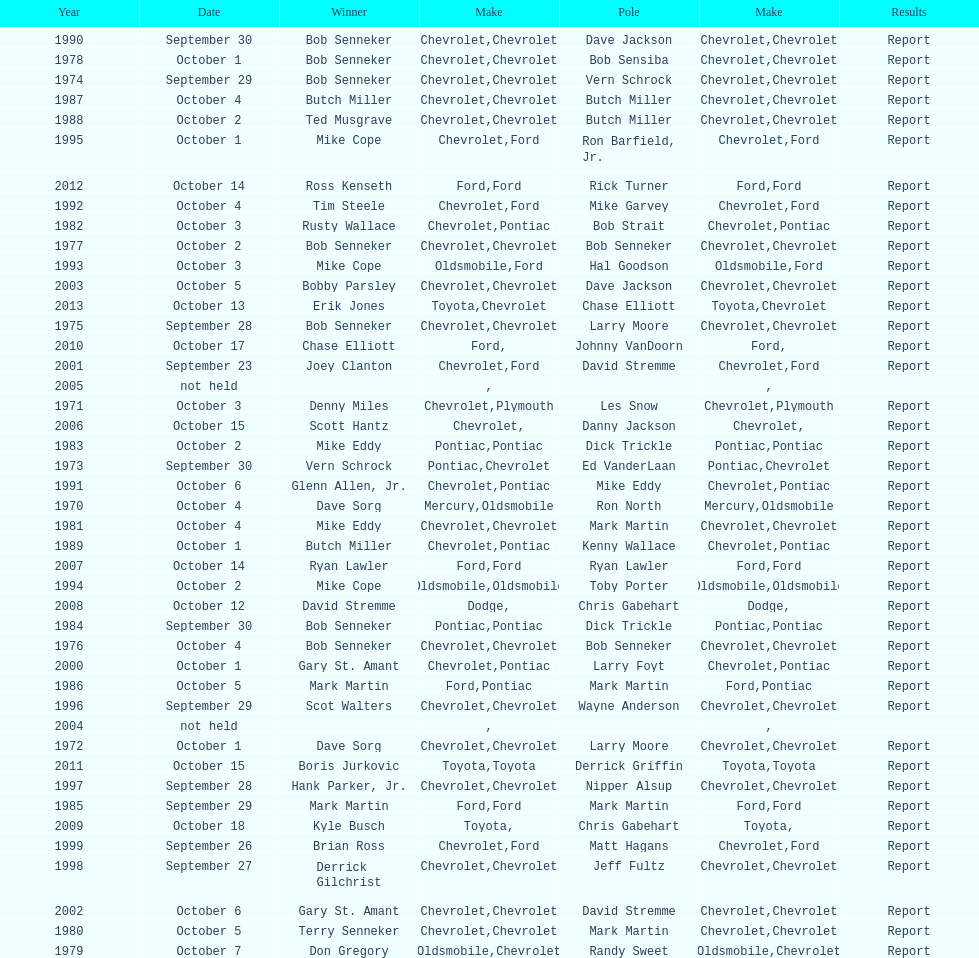Which month held the most winchester 400 races? October. 